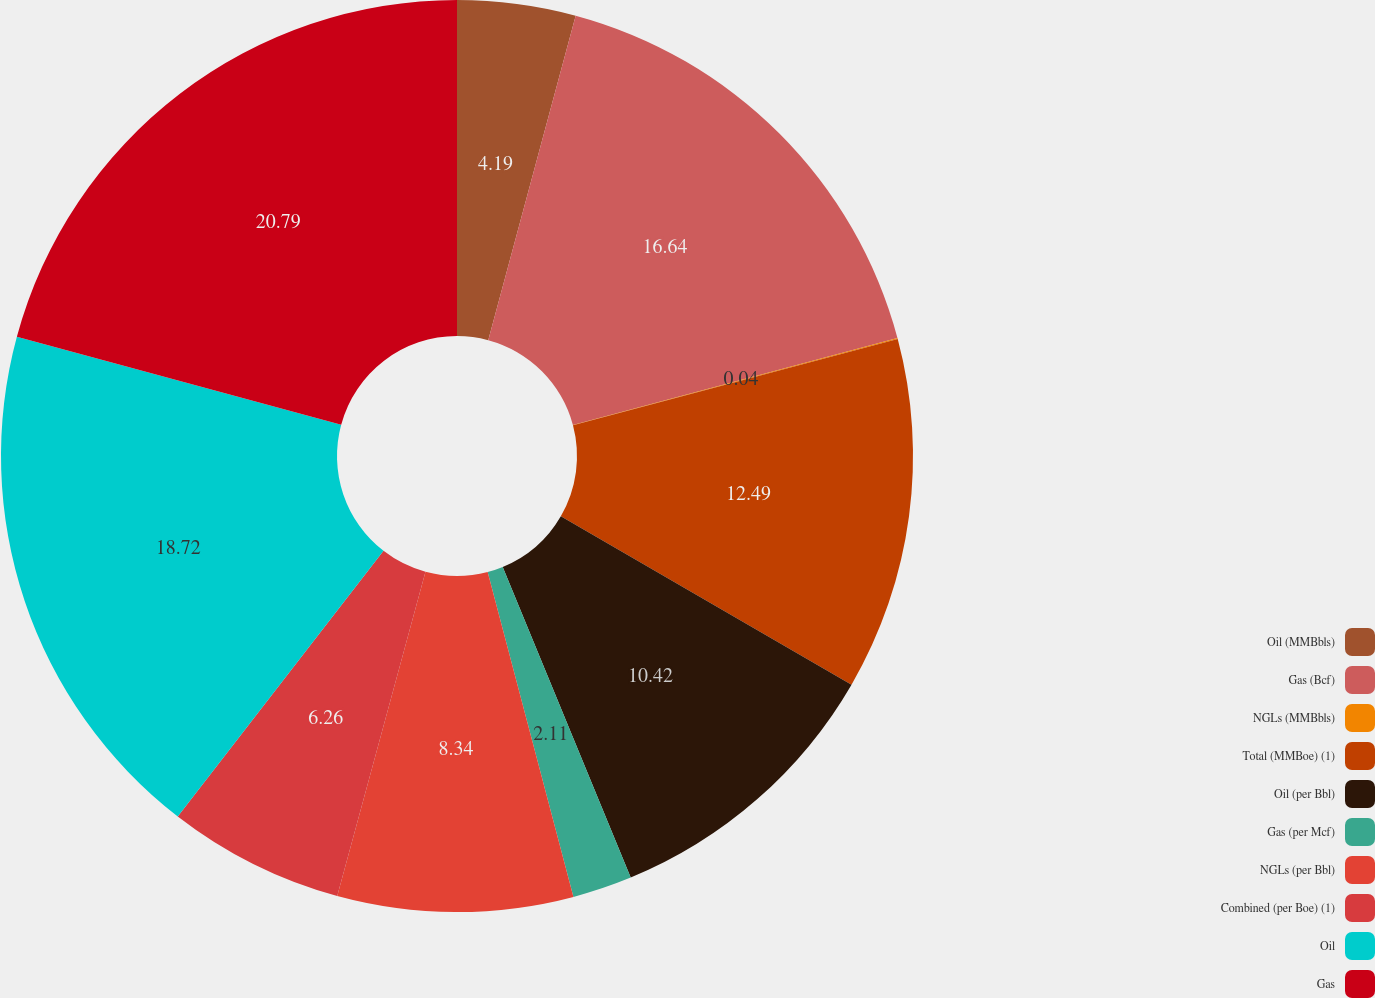Convert chart. <chart><loc_0><loc_0><loc_500><loc_500><pie_chart><fcel>Oil (MMBbls)<fcel>Gas (Bcf)<fcel>NGLs (MMBbls)<fcel>Total (MMBoe) (1)<fcel>Oil (per Bbl)<fcel>Gas (per Mcf)<fcel>NGLs (per Bbl)<fcel>Combined (per Boe) (1)<fcel>Oil<fcel>Gas<nl><fcel>4.19%<fcel>16.64%<fcel>0.04%<fcel>12.49%<fcel>10.42%<fcel>2.11%<fcel>8.34%<fcel>6.26%<fcel>18.72%<fcel>20.79%<nl></chart> 